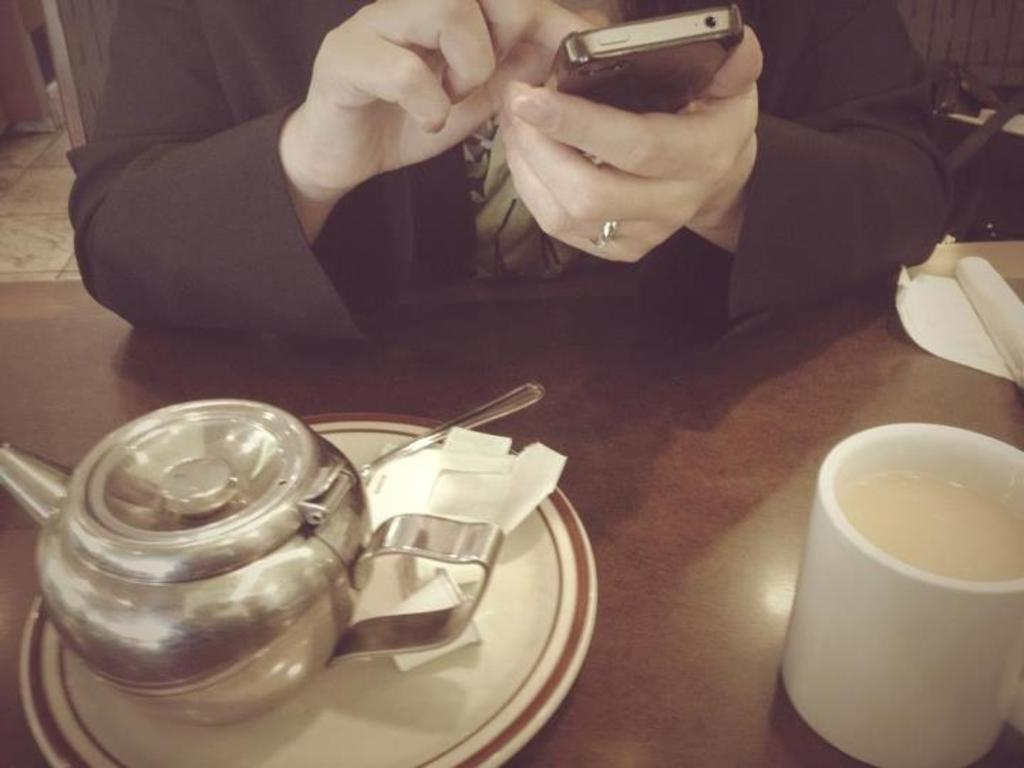Who is present in the image? There is a person in the image. What is the person holding? The person is holding a mobile phone. What type of animal can be seen in the image? There is a cattle in the image. What objects are placed on a table in the image? There is a cup and a plate placed on a table in the image. What type of bread can be seen on the table in the image? There is no bread present on the table in the image. 